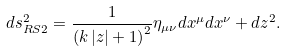Convert formula to latex. <formula><loc_0><loc_0><loc_500><loc_500>d s ^ { 2 } _ { R S 2 } = \frac { 1 } { \left ( k \left | z \right | + 1 \right ) ^ { 2 } } \eta _ { \mu \nu } d x ^ { \mu } d x ^ { \nu } + d z ^ { 2 } .</formula> 